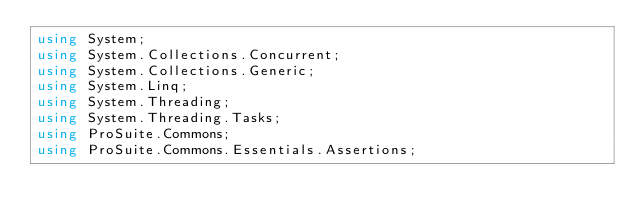<code> <loc_0><loc_0><loc_500><loc_500><_C#_>using System;
using System.Collections.Concurrent;
using System.Collections.Generic;
using System.Linq;
using System.Threading;
using System.Threading.Tasks;
using ProSuite.Commons;
using ProSuite.Commons.Essentials.Assertions;</code> 